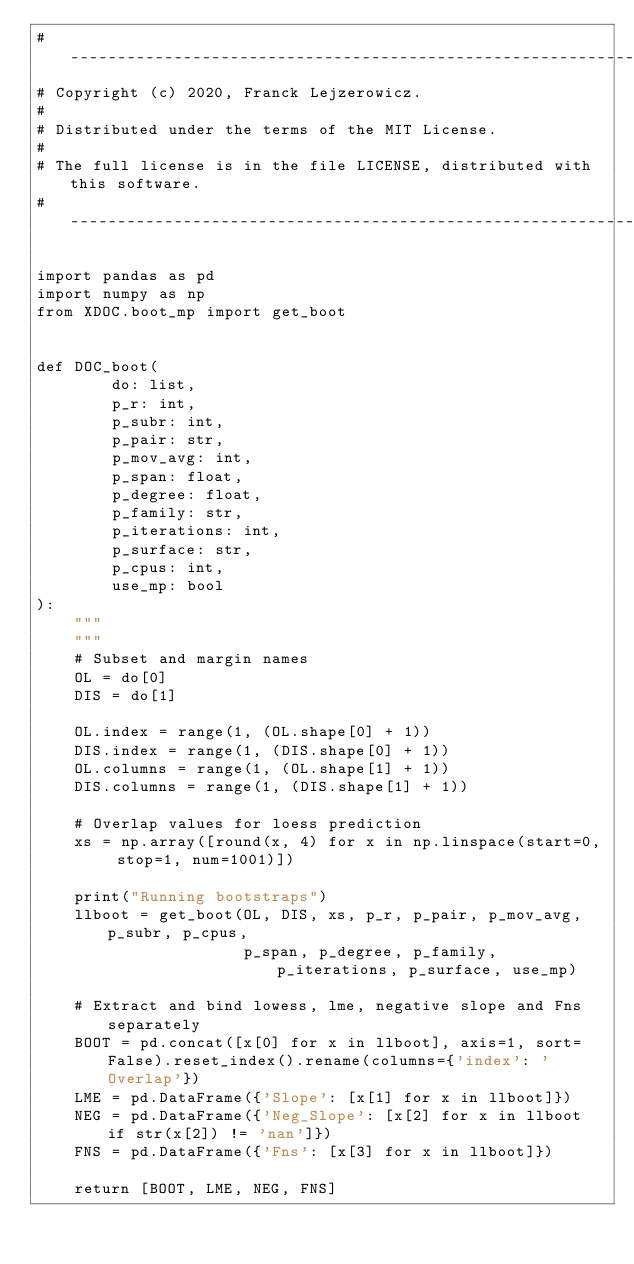Convert code to text. <code><loc_0><loc_0><loc_500><loc_500><_Python_># ----------------------------------------------------------------------------
# Copyright (c) 2020, Franck Lejzerowicz.
#
# Distributed under the terms of the MIT License.
#
# The full license is in the file LICENSE, distributed with this software.
# ----------------------------------------------------------------------------

import pandas as pd
import numpy as np
from XDOC.boot_mp import get_boot


def DOC_boot(
        do: list,
        p_r: int,
        p_subr: int,
        p_pair: str,
        p_mov_avg: int,
        p_span: float,
        p_degree: float,
        p_family: str,
        p_iterations: int,
        p_surface: str,
        p_cpus: int,
        use_mp: bool
):
    """
    """
    # Subset and margin names
    OL = do[0]
    DIS = do[1]

    OL.index = range(1, (OL.shape[0] + 1))
    DIS.index = range(1, (DIS.shape[0] + 1))
    OL.columns = range(1, (OL.shape[1] + 1))
    DIS.columns = range(1, (DIS.shape[1] + 1))

    # Overlap values for loess prediction
    xs = np.array([round(x, 4) for x in np.linspace(start=0, stop=1, num=1001)])

    print("Running bootstraps")
    llboot = get_boot(OL, DIS, xs, p_r, p_pair, p_mov_avg, p_subr, p_cpus,
                      p_span, p_degree, p_family, p_iterations, p_surface, use_mp)

    # Extract and bind lowess, lme, negative slope and Fns separately
    BOOT = pd.concat([x[0] for x in llboot], axis=1, sort=False).reset_index().rename(columns={'index': 'Overlap'})
    LME = pd.DataFrame({'Slope': [x[1] for x in llboot]})
    NEG = pd.DataFrame({'Neg_Slope': [x[2] for x in llboot if str(x[2]) != 'nan']})
    FNS = pd.DataFrame({'Fns': [x[3] for x in llboot]})

    return [BOOT, LME, NEG, FNS]
</code> 